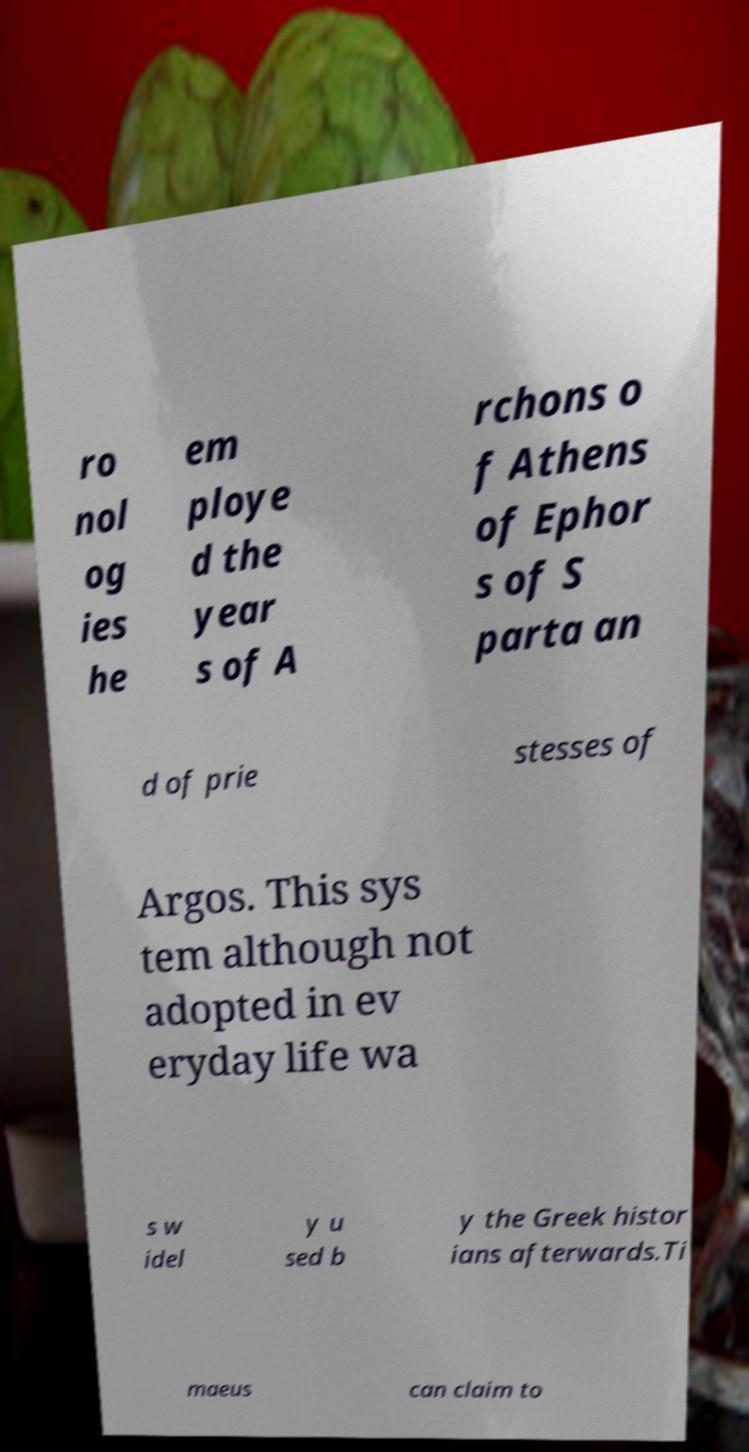Please identify and transcribe the text found in this image. ro nol og ies he em ploye d the year s of A rchons o f Athens of Ephor s of S parta an d of prie stesses of Argos. This sys tem although not adopted in ev eryday life wa s w idel y u sed b y the Greek histor ians afterwards.Ti maeus can claim to 